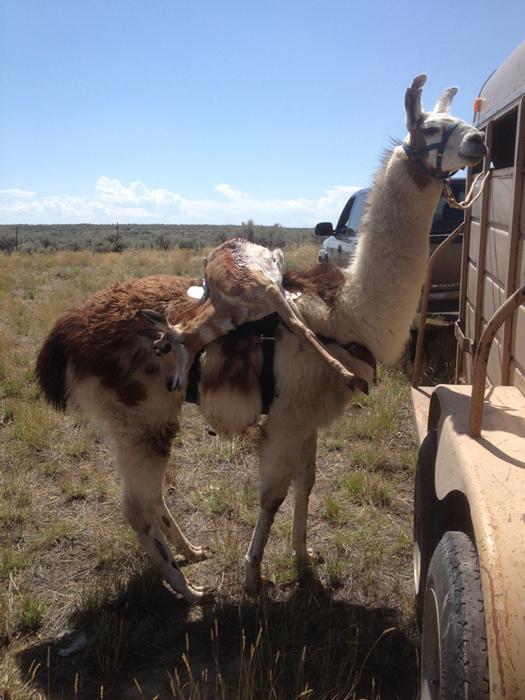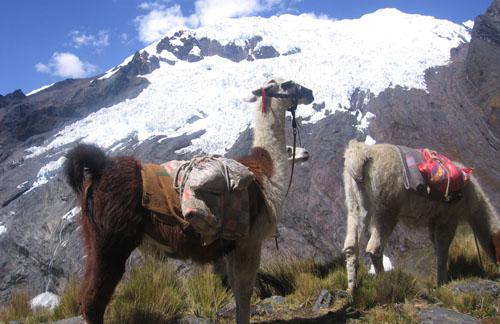The first image is the image on the left, the second image is the image on the right. Given the left and right images, does the statement "A woman in a tank top is standing to the right of a llama and holding a blue rope attached to its harness." hold true? Answer yes or no. No. The first image is the image on the left, the second image is the image on the right. Evaluate the accuracy of this statement regarding the images: "All the llamas have leashes.". Is it true? Answer yes or no. Yes. 